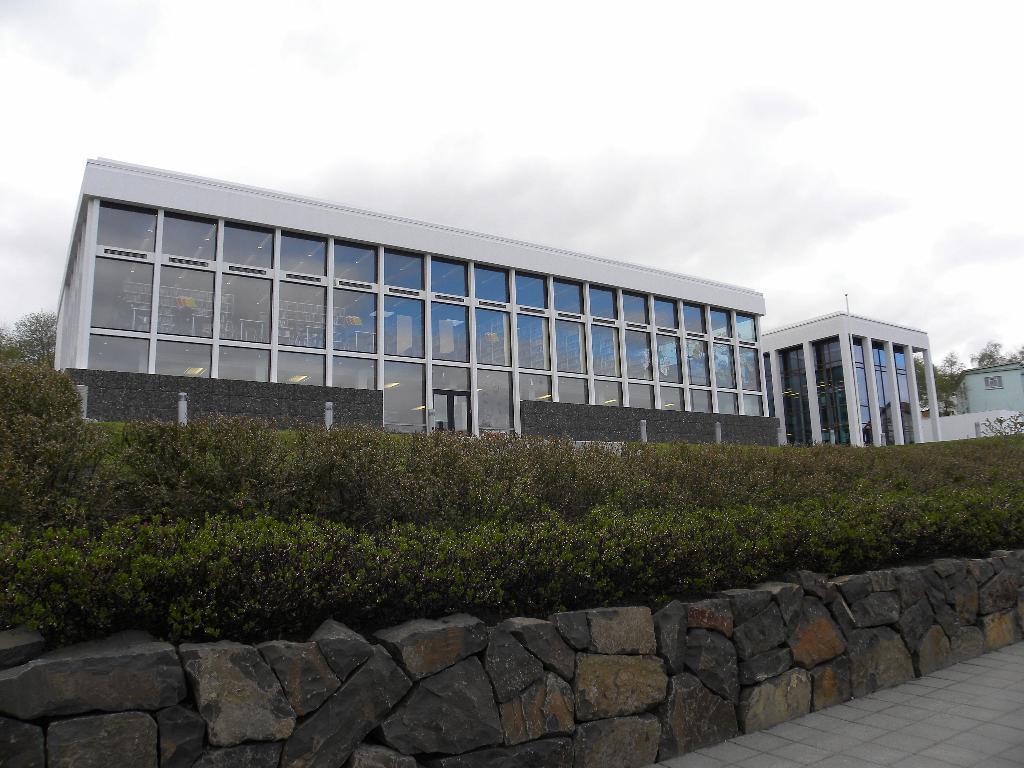Please provide a concise description of this image. Here we can see buildings, plants, and trees. There is a rock wall. In the background we can see sky. 